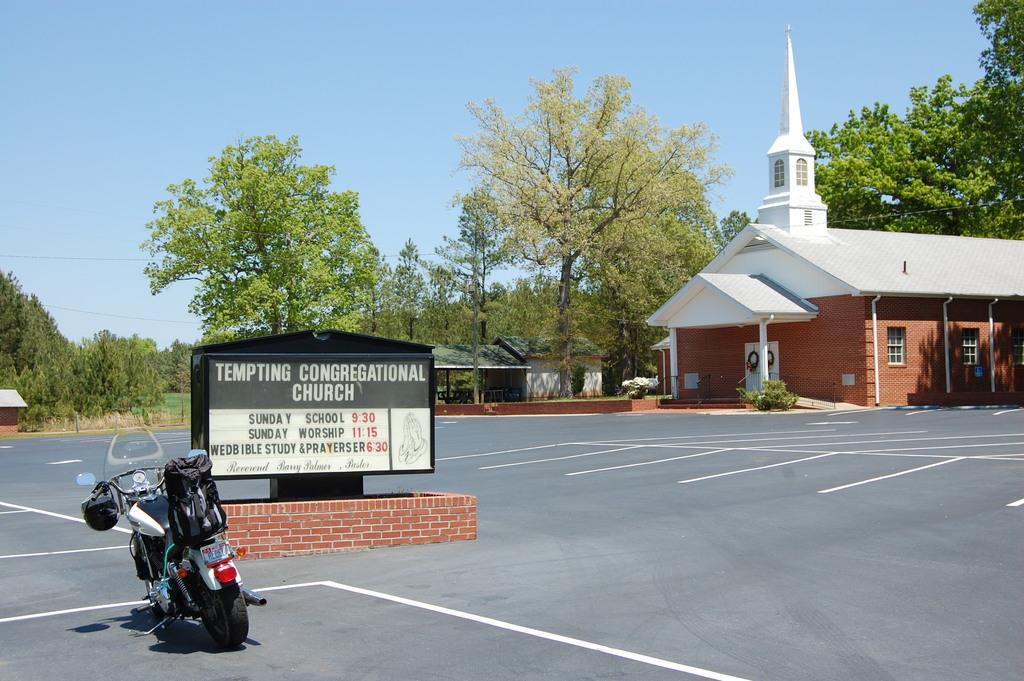What can be seen in the background of the image? There is a building, trees, and the sky visible in the background of the image. What object is present in the image with writing on it? There is a board in the image with writing on it. What markings are on the ground in the image? There are white lines on the ground. What is located on the left side of the image? There is a vehicle on the left side of the image. What type of class is being held in the image? There is no class present in the image. Where is the market located in the image? There is no market present in the image. 